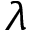Convert formula to latex. <formula><loc_0><loc_0><loc_500><loc_500>\lambda</formula> 